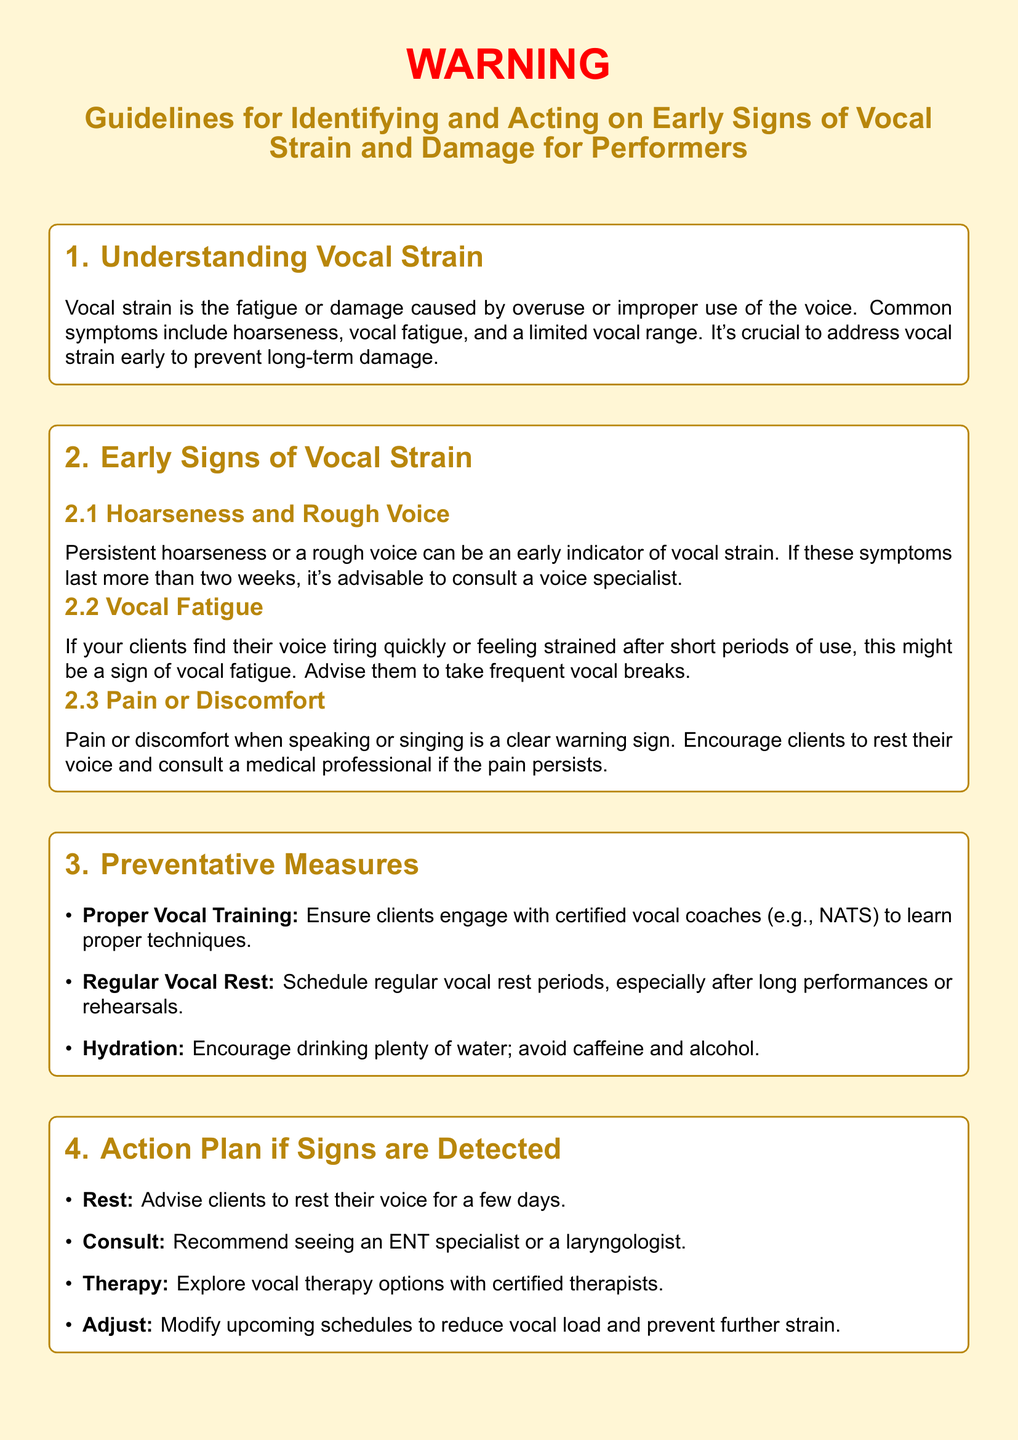What is the main focus of the guidelines? The guidelines primarily focus on identifying and acting on early signs of vocal strain and damage for performers.
Answer: Identifying and acting on early signs of vocal strain and damage for performers What should clients do if they experience persistent hoarseness? Persistent hoarseness for more than two weeks is advised to consult a voice specialist.
Answer: Consult a voice specialist What are two early signs of vocal strain mentioned? The document lists hoarseness and vocal fatigue as early signs of vocal strain.
Answer: Hoarseness and vocal fatigue How should performers maintain vocal health according to the preventative measures? Performers should engage with certified vocal coaches and schedule vocal rest periods.
Answer: Engage with certified vocal coaches and schedule vocal rest periods What is one action recommended if vocal strain signs are detected? One action recommended is to rest the voice for a few days.
Answer: Rest the voice for a few days Which organization is mentioned as a resource for vocal health? Vocapedia is listed as a resource providing information on vocal health.
Answer: Vocapedia What is the color used for the warning label background? The background color of the warning label is RGB 255, 246, 213.
Answer: RGB 255, 246, 213 What should be avoided to maintain hydration? Caffeine and alcohol should be avoided to maintain hydration.
Answer: Caffeine and alcohol 